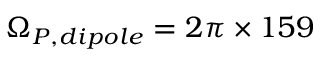Convert formula to latex. <formula><loc_0><loc_0><loc_500><loc_500>\Omega _ { P , d i p o l e } = 2 \pi \times 1 5 9</formula> 